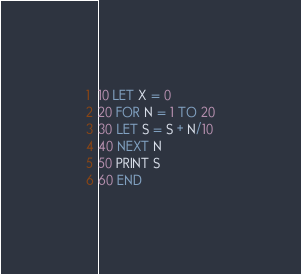<code> <loc_0><loc_0><loc_500><loc_500><_VisualBasic_>10 LET X = 0
20 FOR N = 1 TO 20
30 LET S = S + N/10
40 NEXT N
50 PRINT S
60 END
</code> 